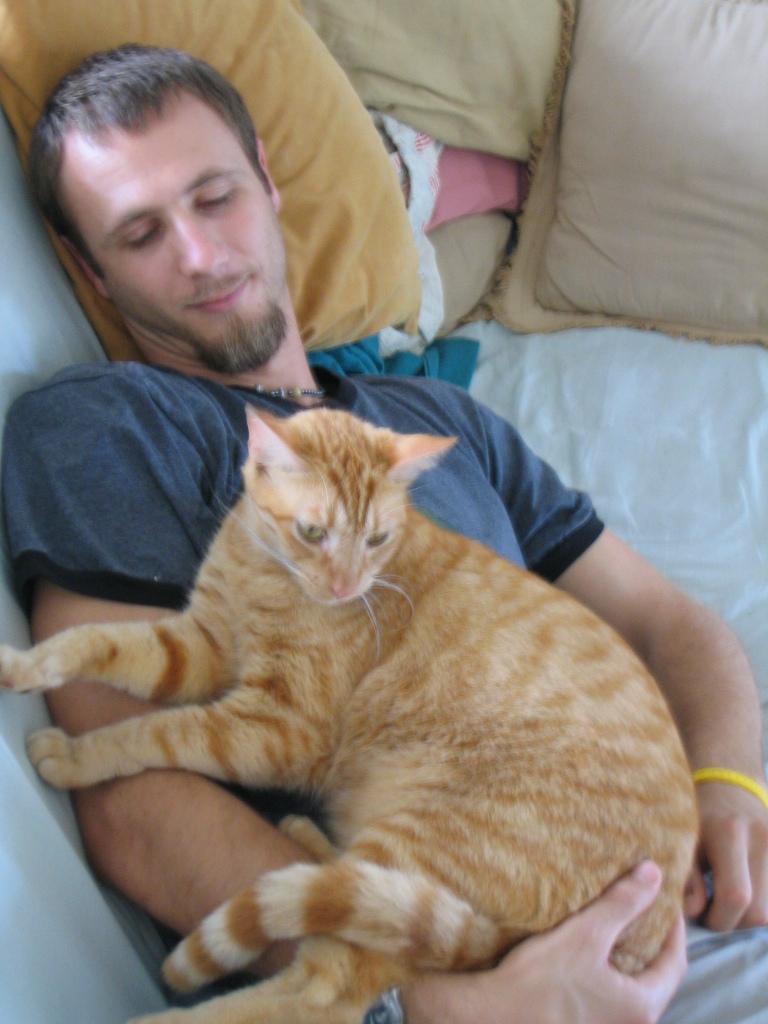Could you give a brief overview of what you see in this image? In this picture we can see a man who is laying on the bed. These are the pillows and there is a cat. 